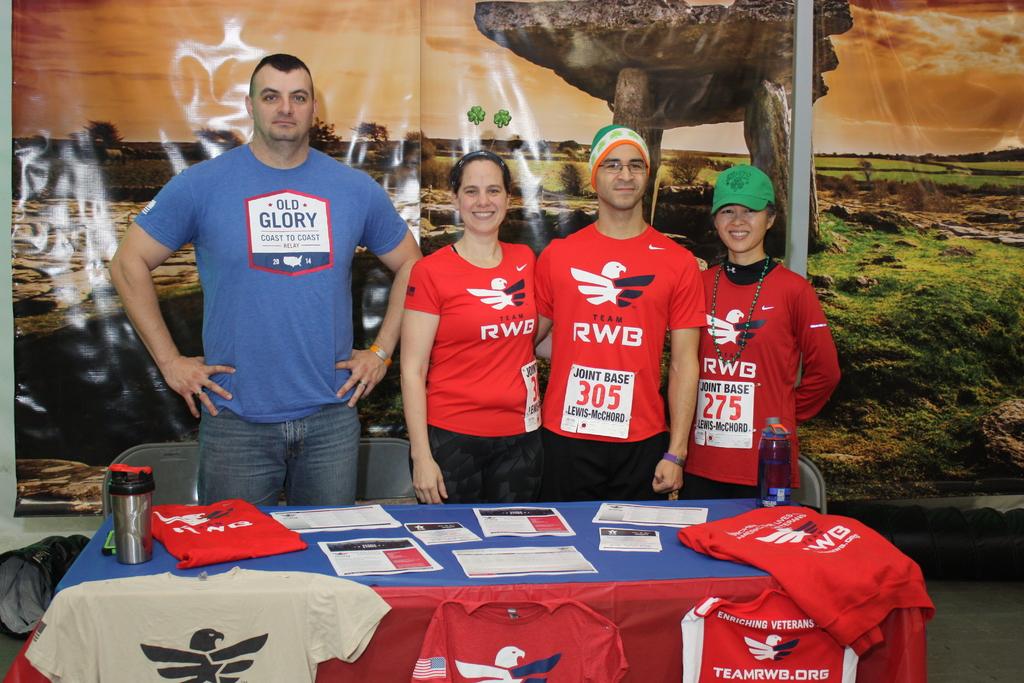What kind of glory does his shirt say?
Offer a terse response. Old. What is the man race number?
Your answer should be very brief. 305. 